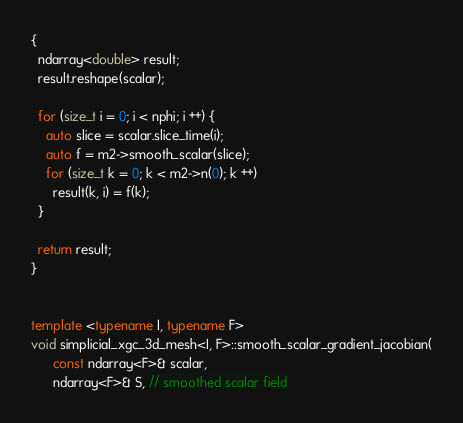Convert code to text. <code><loc_0><loc_0><loc_500><loc_500><_C++_>{
  ndarray<double> result;
  result.reshape(scalar);
  
  for (size_t i = 0; i < nphi; i ++) {
    auto slice = scalar.slice_time(i);
    auto f = m2->smooth_scalar(slice);
    for (size_t k = 0; k < m2->n(0); k ++)
      result(k, i) = f(k);
  }

  return result;
}
  

template <typename I, typename F>
void simplicial_xgc_3d_mesh<I, F>::smooth_scalar_gradient_jacobian(
      const ndarray<F>& scalar, 
      ndarray<F>& S, // smoothed scalar field</code> 